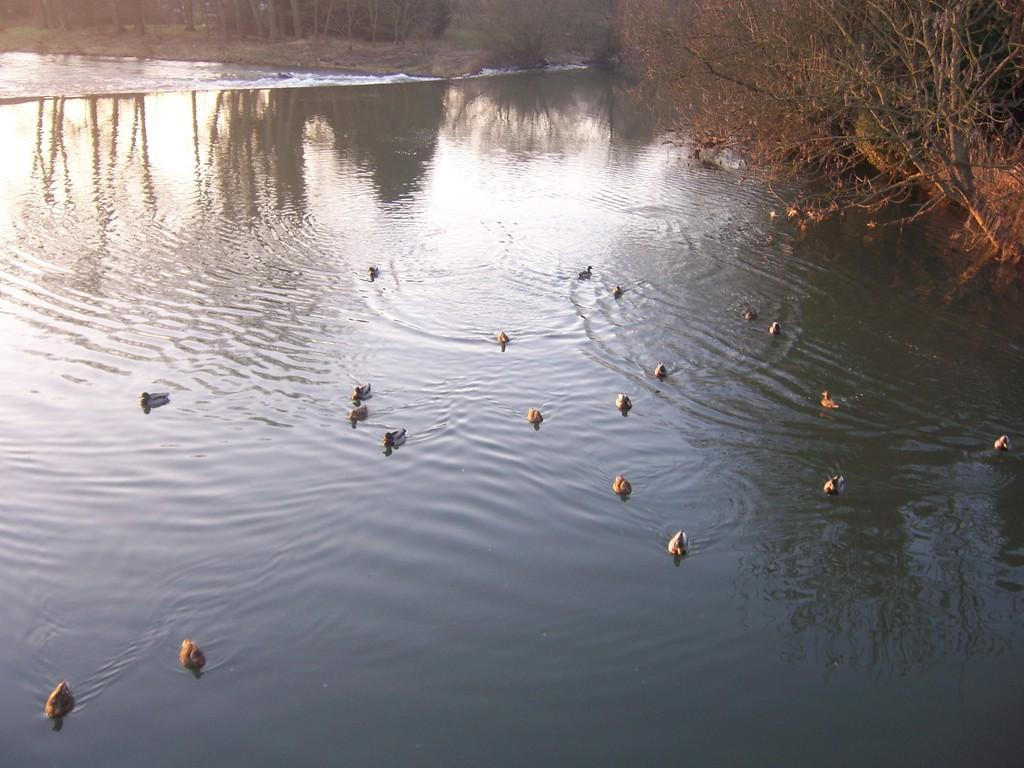What type of animals can be seen in the water in the image? There are birds in the water in the image. What type of vegetation is present in the image? There are trees in the image. What word is being spoken by the men in the story depicted in the image? There are no men or story present in the image; it features birds in the water and trees. 